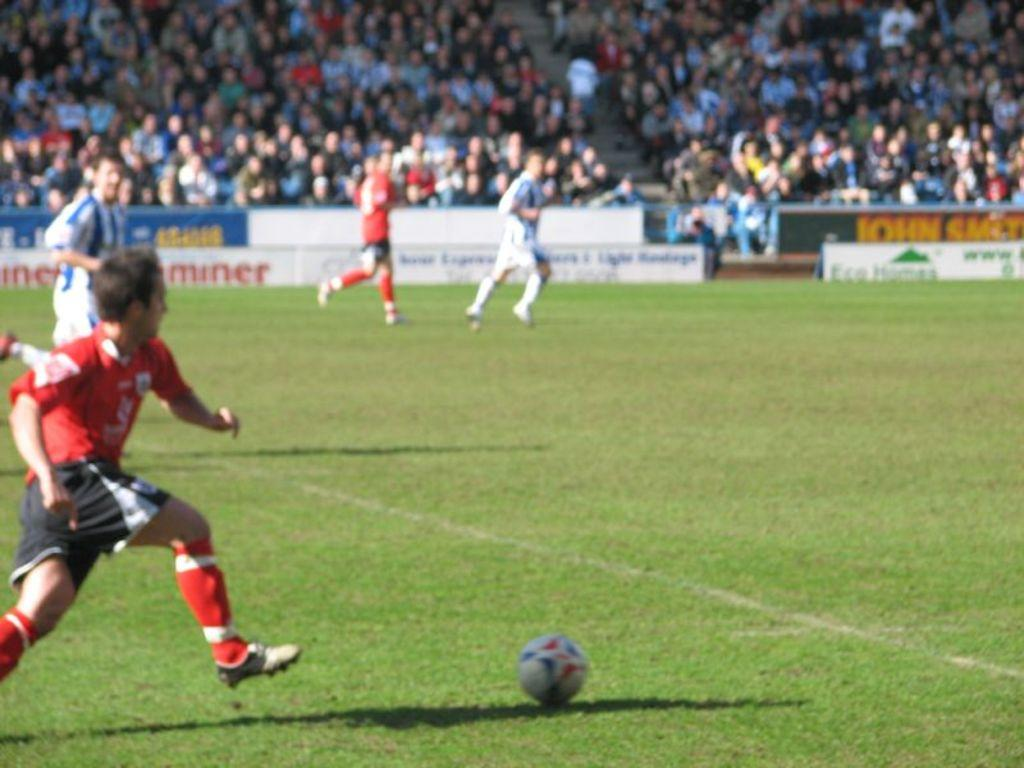<image>
Describe the image concisely. Players race down the field towards a sign that says John Smith 